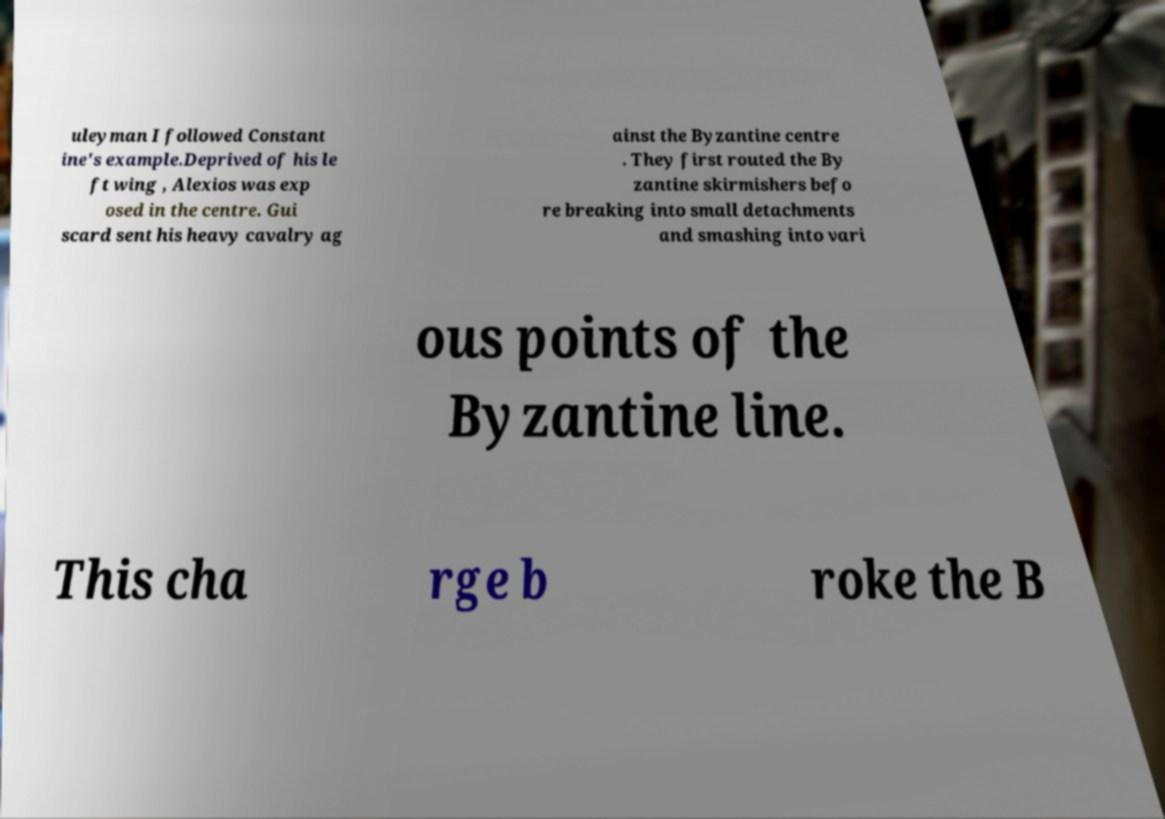Can you accurately transcribe the text from the provided image for me? uleyman I followed Constant ine's example.Deprived of his le ft wing , Alexios was exp osed in the centre. Gui scard sent his heavy cavalry ag ainst the Byzantine centre . They first routed the By zantine skirmishers befo re breaking into small detachments and smashing into vari ous points of the Byzantine line. This cha rge b roke the B 